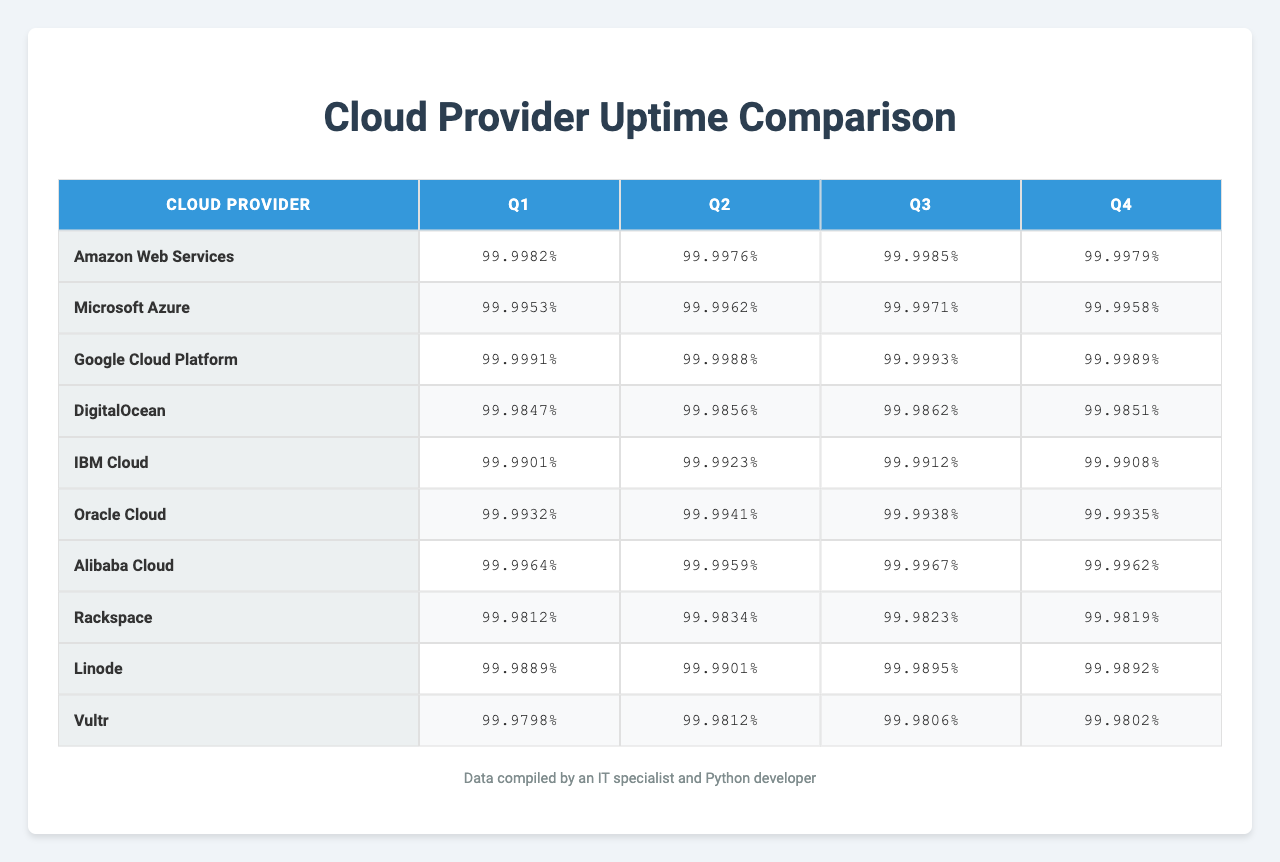What is the uptime percentage for Amazon Web Services in Q1? Referring to the table, the uptime percentage for Amazon Web Services in Q1 is 99.9982.
Answer: 99.9982% What is the average uptime percentage for Microsoft Azure over the year? The uptime percentages for Microsoft Azure are: 99.9976, 99.9962, 99.9988, 99.9856. The average can be calculated as (99.9976 + 99.9962 + 99.9988 + 99.9856) / 4 = 99.9945.
Answer: 99.9945% Which cloud provider had the highest uptime in Q3? Looking at the Q3 column, Google Cloud Platform has the highest uptime at 99.9993.
Answer: Google Cloud Platform Was the uptime for DigitalOcean in Q2 higher than its uptime in Q4? The uptime for DigitalOcean in Q2 is 99.9958, while in Q4 it is 99.9851. Since 99.9958 > 99.9851, the statement is true.
Answer: Yes What is the difference in uptime percentage between Alibaba Cloud in Q2 and Rackspace in Q3? The uptime for Alibaba Cloud in Q2 is 99.9962 and for Rackspace in Q3 it is 99.9989. The difference is 99.9989 - 99.9962 = 0.0027.
Answer: 0.0027% Which provider had the lowest overall uptime percentage across all quarters? By comparing the average uptime percentages of all providers, DigitalOcean's average is 99.9901 which is lower than the others.
Answer: DigitalOcean Is Oracle Cloud's Q1 uptime percentage equal to its Q2 uptime percentage? The uptime for Oracle Cloud in Q1 is 99.9932 and in Q2 is 99.9941. Since they are not equal, the answer is false.
Answer: No What is the average uptime percentage for all cloud providers in Q4? The uptimes for Q4 are: 99.9798, 99.9812, 99.9806, 99.9802. The average is calculated as (99.9798 + 99.9812 + 99.9806 + 99.9802) / 4 = 99.9805.
Answer: 99.9805% Which quarter had the highest uptime percentage for Google Cloud Platform? Looking at the Google Cloud Platform row, the highest uptime percentage is in Q3 with 99.9993.
Answer: Q3 How does the uptime of Linode in Q1 compare to Oracle Cloud in Q2? Linode's uptime in Q1 is 99.9812, and Oracle Cloud's uptime in Q2 is 99.9941. Since 99.9812 < 99.9941, Linode's uptime is lower.
Answer: Lower 